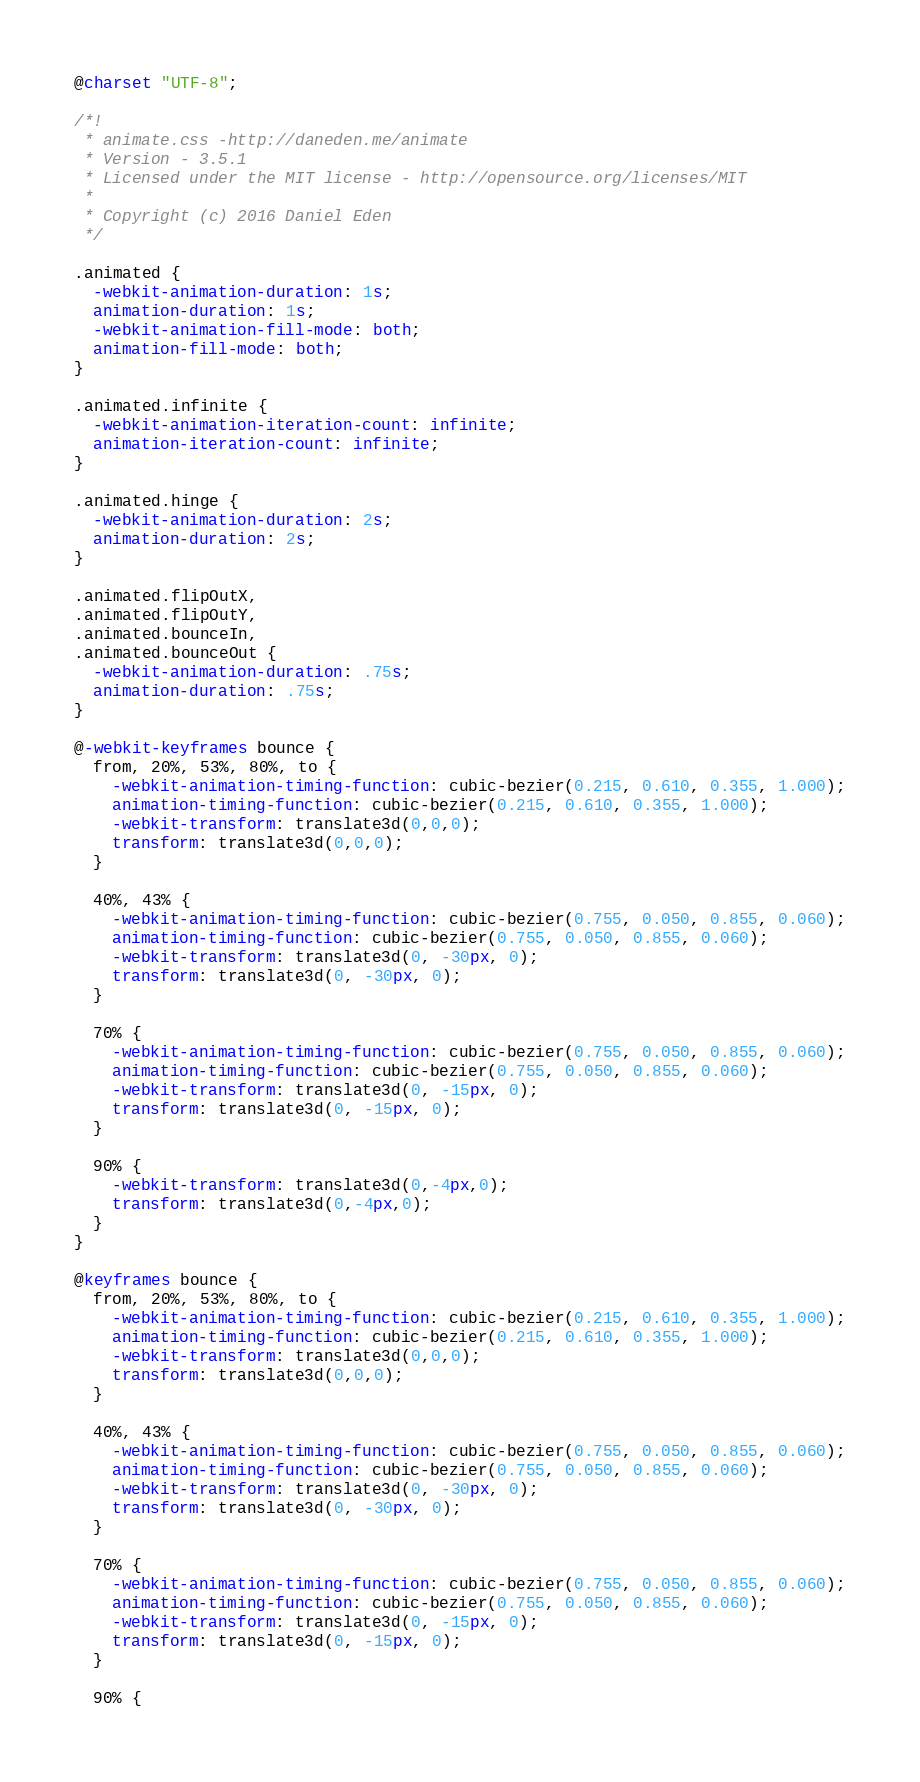<code> <loc_0><loc_0><loc_500><loc_500><_CSS_>@charset "UTF-8";

/*!
 * animate.css -http://daneden.me/animate
 * Version - 3.5.1
 * Licensed under the MIT license - http://opensource.org/licenses/MIT
 *
 * Copyright (c) 2016 Daniel Eden
 */

.animated {
  -webkit-animation-duration: 1s;
  animation-duration: 1s;
  -webkit-animation-fill-mode: both;
  animation-fill-mode: both;
}

.animated.infinite {
  -webkit-animation-iteration-count: infinite;
  animation-iteration-count: infinite;
}

.animated.hinge {
  -webkit-animation-duration: 2s;
  animation-duration: 2s;
}

.animated.flipOutX,
.animated.flipOutY,
.animated.bounceIn,
.animated.bounceOut {
  -webkit-animation-duration: .75s;
  animation-duration: .75s;
}

@-webkit-keyframes bounce {
  from, 20%, 53%, 80%, to {
    -webkit-animation-timing-function: cubic-bezier(0.215, 0.610, 0.355, 1.000);
    animation-timing-function: cubic-bezier(0.215, 0.610, 0.355, 1.000);
    -webkit-transform: translate3d(0,0,0);
    transform: translate3d(0,0,0);
  }

  40%, 43% {
    -webkit-animation-timing-function: cubic-bezier(0.755, 0.050, 0.855, 0.060);
    animation-timing-function: cubic-bezier(0.755, 0.050, 0.855, 0.060);
    -webkit-transform: translate3d(0, -30px, 0);
    transform: translate3d(0, -30px, 0);
  }

  70% {
    -webkit-animation-timing-function: cubic-bezier(0.755, 0.050, 0.855, 0.060);
    animation-timing-function: cubic-bezier(0.755, 0.050, 0.855, 0.060);
    -webkit-transform: translate3d(0, -15px, 0);
    transform: translate3d(0, -15px, 0);
  }

  90% {
    -webkit-transform: translate3d(0,-4px,0);
    transform: translate3d(0,-4px,0);
  }
}

@keyframes bounce {
  from, 20%, 53%, 80%, to {
    -webkit-animation-timing-function: cubic-bezier(0.215, 0.610, 0.355, 1.000);
    animation-timing-function: cubic-bezier(0.215, 0.610, 0.355, 1.000);
    -webkit-transform: translate3d(0,0,0);
    transform: translate3d(0,0,0);
  }

  40%, 43% {
    -webkit-animation-timing-function: cubic-bezier(0.755, 0.050, 0.855, 0.060);
    animation-timing-function: cubic-bezier(0.755, 0.050, 0.855, 0.060);
    -webkit-transform: translate3d(0, -30px, 0);
    transform: translate3d(0, -30px, 0);
  }

  70% {
    -webkit-animation-timing-function: cubic-bezier(0.755, 0.050, 0.855, 0.060);
    animation-timing-function: cubic-bezier(0.755, 0.050, 0.855, 0.060);
    -webkit-transform: translate3d(0, -15px, 0);
    transform: translate3d(0, -15px, 0);
  }

  90% {</code> 